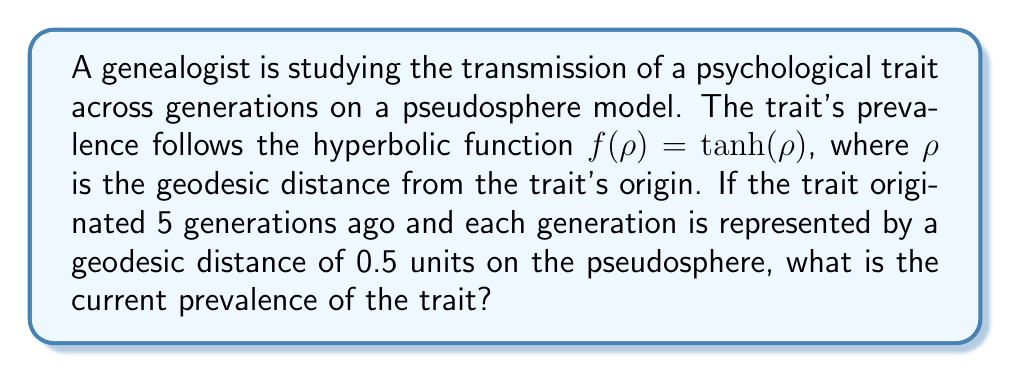Teach me how to tackle this problem. To solve this problem, we'll follow these steps:

1) First, we need to calculate the total geodesic distance $\rho$ from the trait's origin to the current generation:
   
   $\rho = 5 \text{ generations} \times 0.5 \text{ units/generation} = 2.5 \text{ units}$

2) The prevalence of the trait is given by the hyperbolic function:

   $f(\rho) = \tanh(\rho)$

3) We need to calculate $\tanh(2.5)$. The hyperbolic tangent is defined as:

   $\tanh(x) = \frac{\sinh(x)}{\cosh(x)} = \frac{e^x - e^{-x}}{e^x + e^{-x}}$

4) Let's calculate this step-by-step:

   $e^{2.5} \approx 12.1825$
   $e^{-2.5} \approx 0.0821$

   $\tanh(2.5) = \frac{12.1825 - 0.0821}{12.1825 + 0.0821} = \frac{12.1004}{12.2646}$

5) Calculating this division:

   $\tanh(2.5) \approx 0.9866$

Therefore, the current prevalence of the trait, 5 generations after its origin, is approximately 0.9866 or 98.66%.
Answer: $0.9866$ 